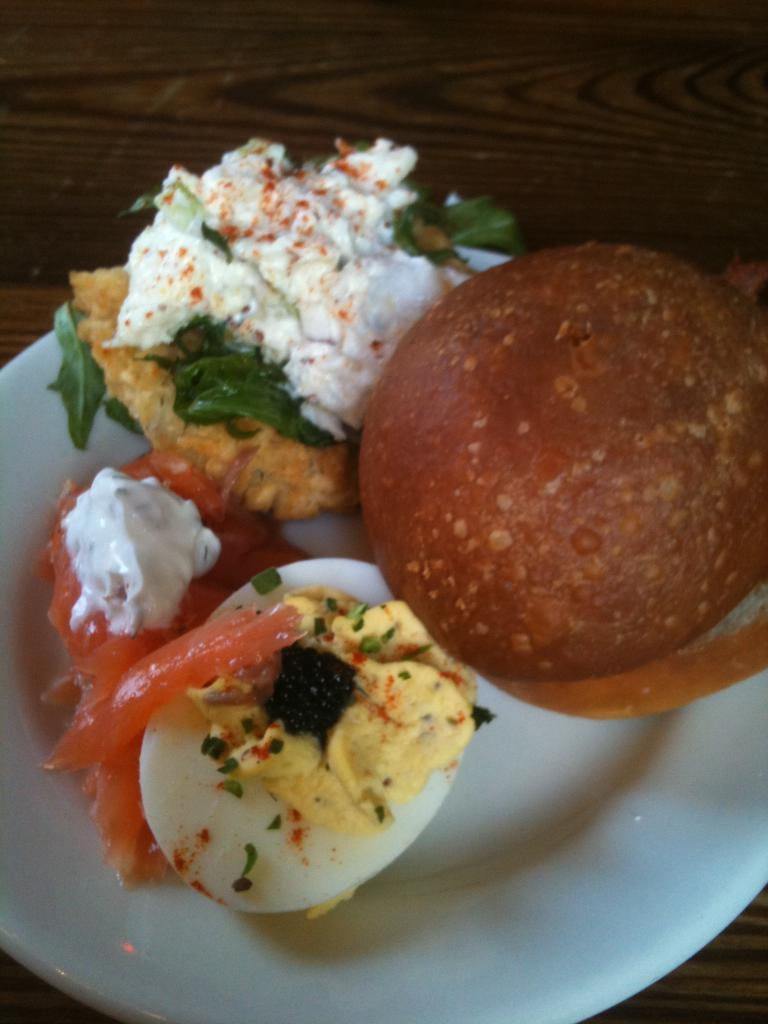What is the plate resting on in the image? The plate is on a wooden plank in the image. Where is the wooden plank located? The wooden plank is on a table in the image. What types of food items can be seen on the table? There are egg slices, cream, and a sweet on the table in the image. What type of knot is being used to secure the goat in the image? There is no goat present in the image, and therefore no knot or securing method can be observed. 